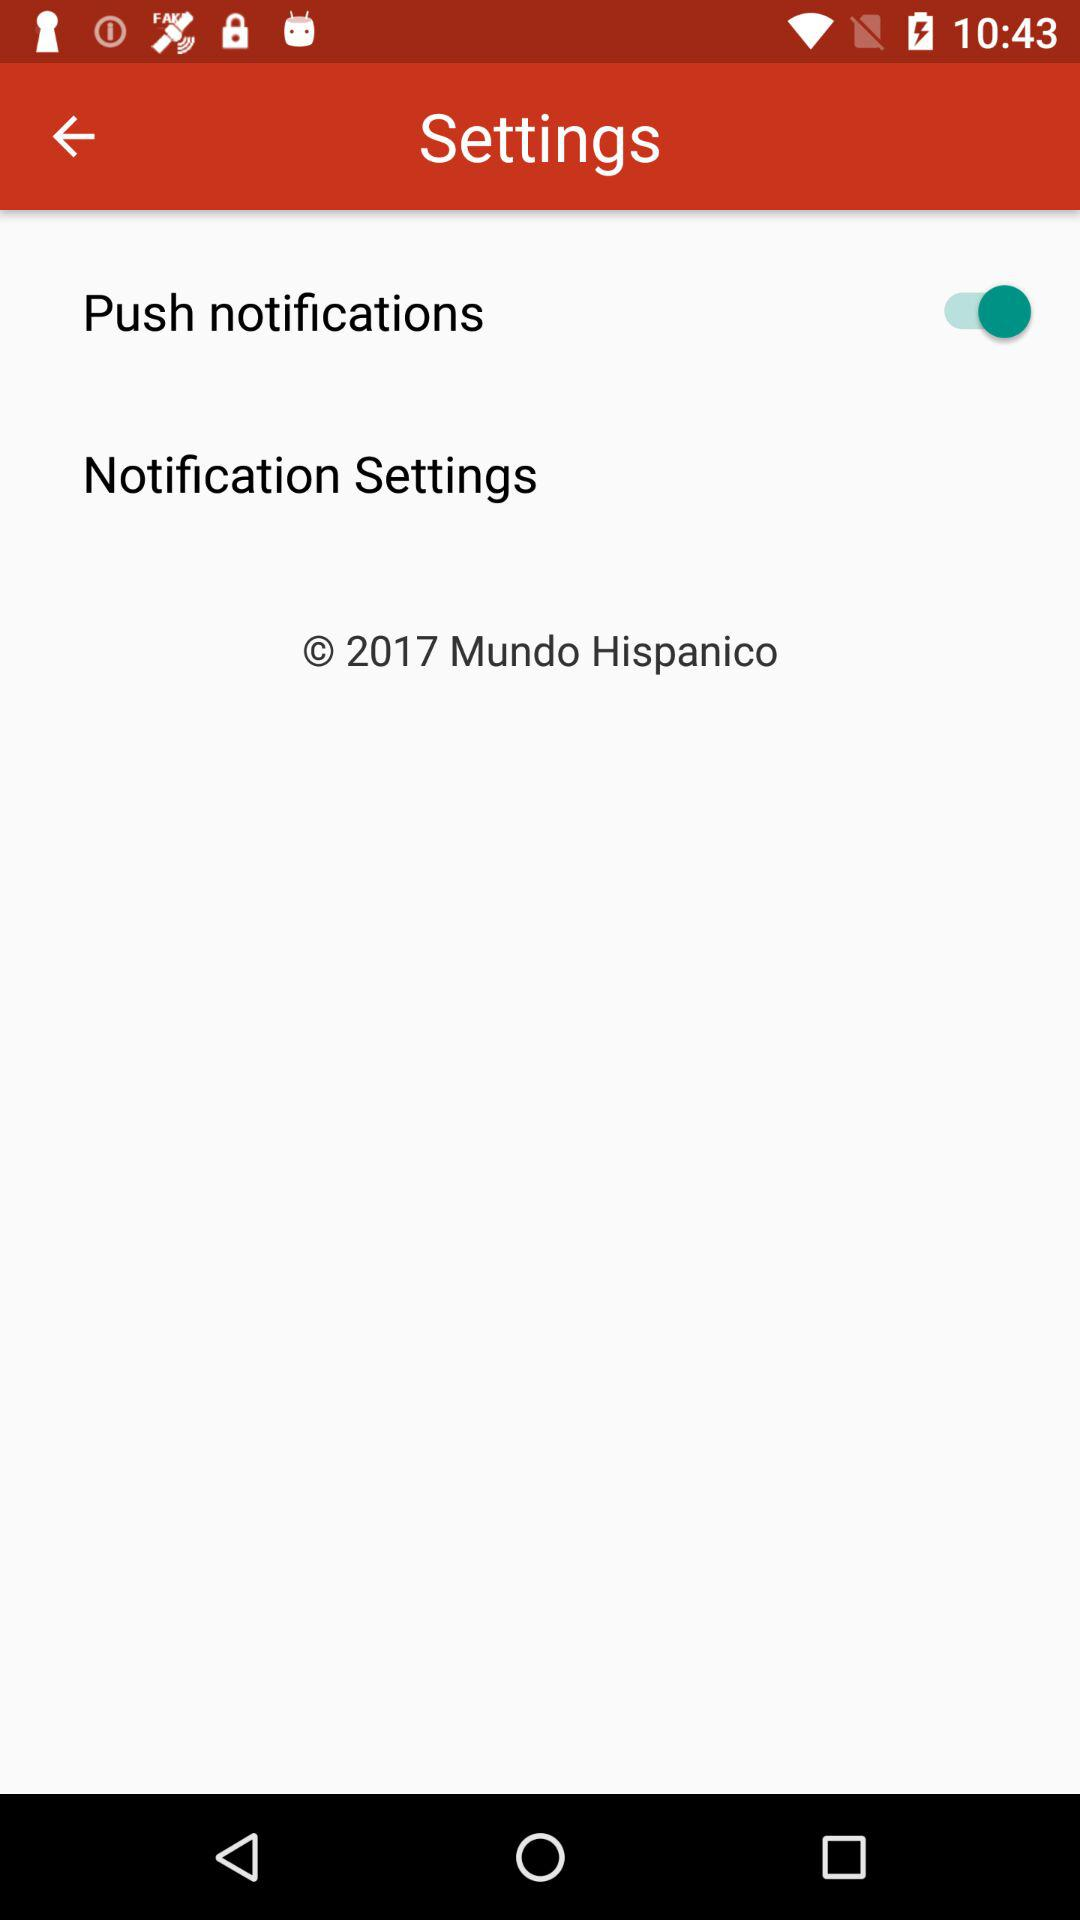What is the status of "Push notifications"? The status is "on". 